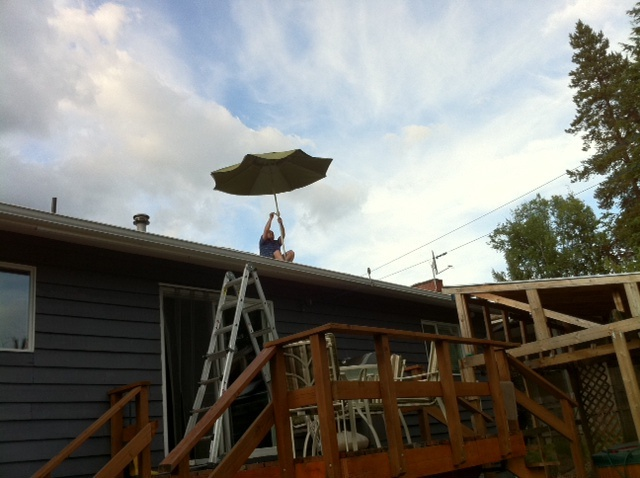Describe the objects in this image and their specific colors. I can see umbrella in darkgray, black, gray, and lightgray tones, chair in darkgray, black, maroon, and gray tones, chair in darkgray, black, and gray tones, people in darkgray, black, and gray tones, and dining table in darkgray, gray, darkgreen, and black tones in this image. 